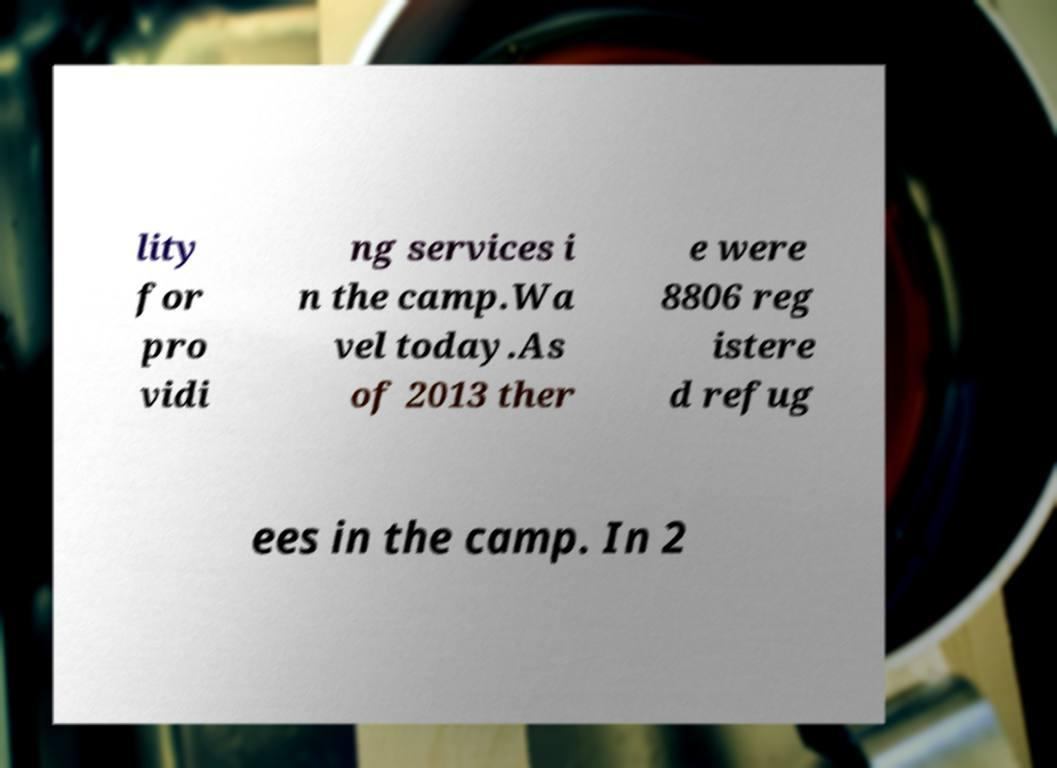Please read and relay the text visible in this image. What does it say? lity for pro vidi ng services i n the camp.Wa vel today.As of 2013 ther e were 8806 reg istere d refug ees in the camp. In 2 